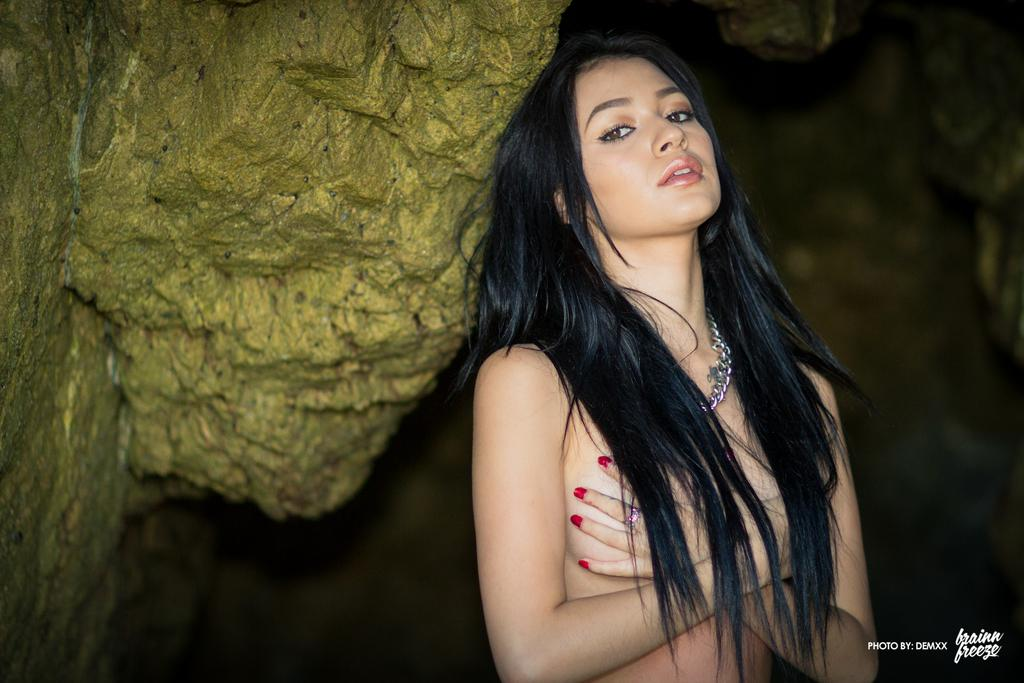Who is present in the image? There is a woman in the image. What is the woman wearing around her neck? The woman is wearing a chain around her neck. What type of object can be seen in the image besides the woman? There is a rock in the image. What colors are visible on the rock? The rock has yellow and green colors. How would you describe the background of the image? The background of the image is dark. What type of popcorn is being served in the image? There is no popcorn present in the image. Can you see a blade in the woman's hand in the image? There is no blade visible in the woman's hand in the image. 